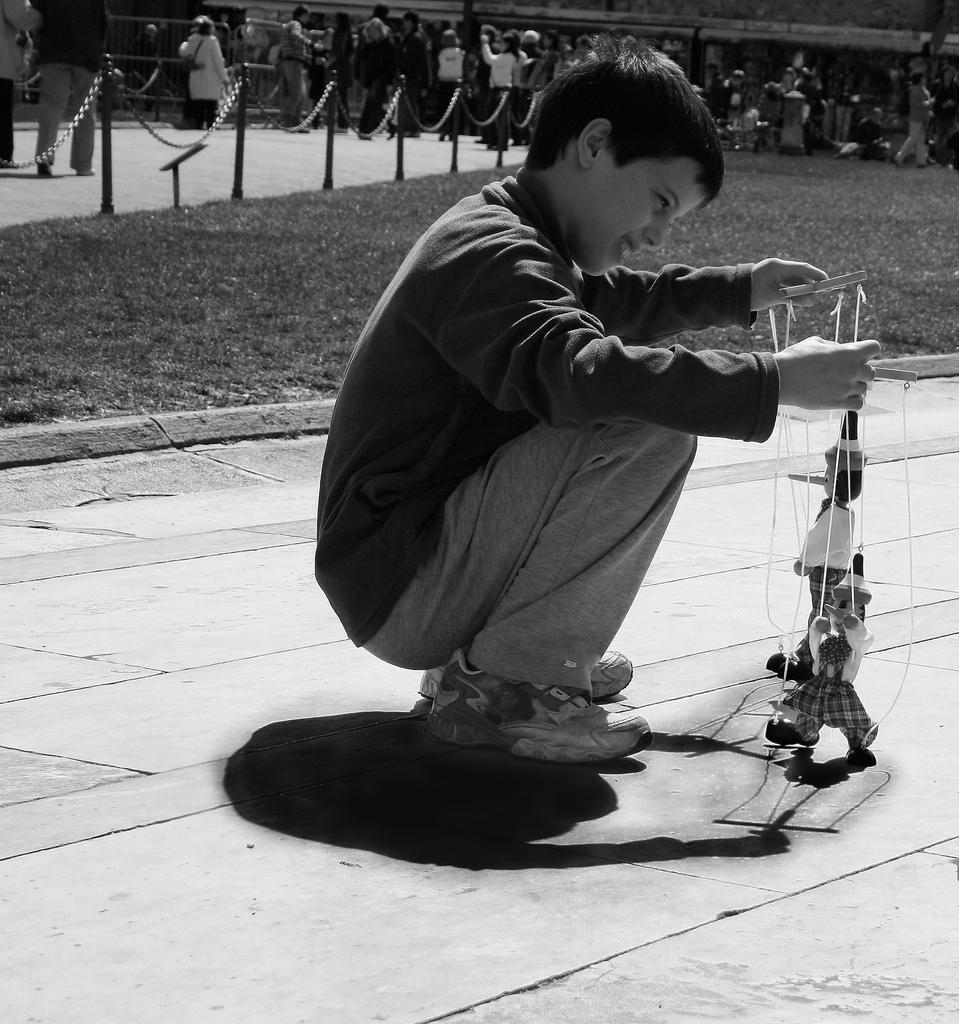What is the color scheme of the image? The image is black and white. What is the boy in the image doing? The boy is sitting on the road and playing with toys. What type of terrain is visible behind the boy? There is grassy land behind the boy. What is separating the grassy land from the road? There is fencing behind the boy. Can you describe the people visible behind the boy? There are people visible behind the boy, but their specific features cannot be determined due to the black and white color scheme. What type of test is the boy taking in the image? There is no indication in the image that the boy is taking a test. The boy is simply sitting on the road and playing with toys. 